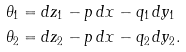<formula> <loc_0><loc_0><loc_500><loc_500>\theta _ { 1 } & = d z _ { 1 } - p \, d x - q _ { 1 } \, d y _ { 1 } \\ \theta _ { 2 } & = d z _ { 2 } - p \, d x - q _ { 2 } \, d y _ { 2 } .</formula> 